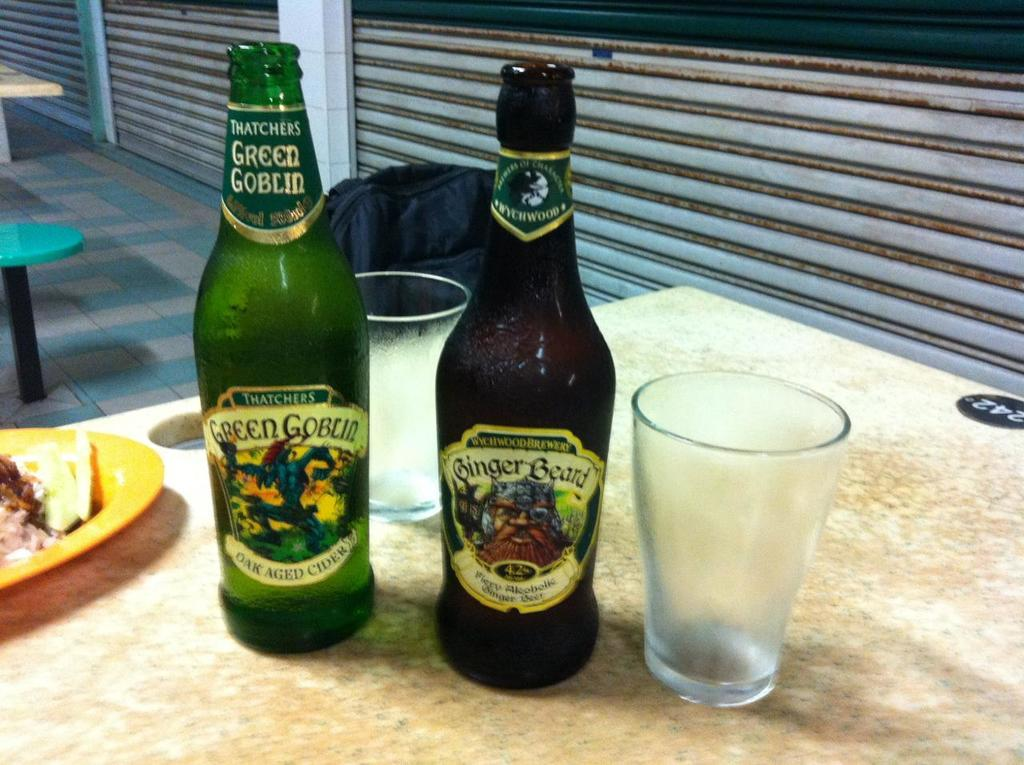<image>
Present a compact description of the photo's key features. A bottle of Green Gobbled cider next to a bottle of Ginger Beard. 